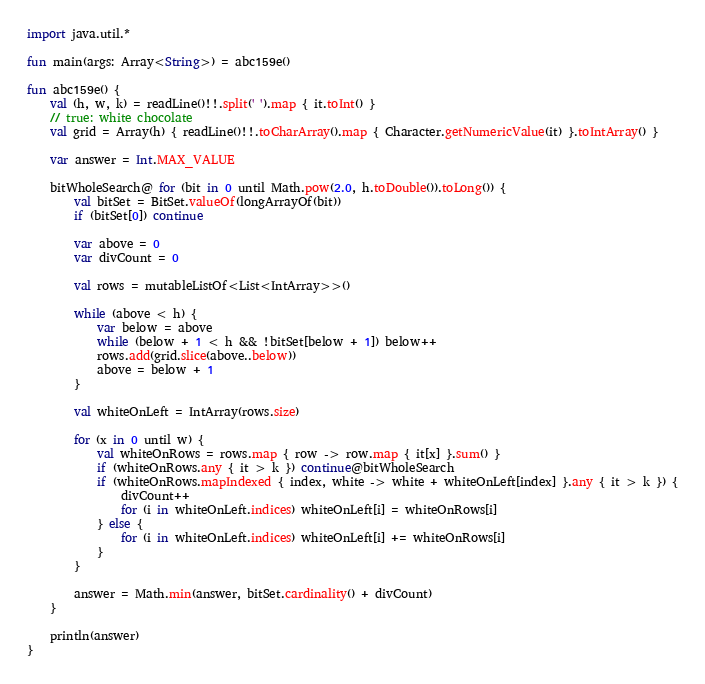Convert code to text. <code><loc_0><loc_0><loc_500><loc_500><_Kotlin_>import java.util.*

fun main(args: Array<String>) = abc159e()

fun abc159e() {
    val (h, w, k) = readLine()!!.split(' ').map { it.toInt() }
    // true: white chocolate
    val grid = Array(h) { readLine()!!.toCharArray().map { Character.getNumericValue(it) }.toIntArray() }

    var answer = Int.MAX_VALUE

    bitWholeSearch@ for (bit in 0 until Math.pow(2.0, h.toDouble()).toLong()) {
        val bitSet = BitSet.valueOf(longArrayOf(bit))
        if (bitSet[0]) continue

        var above = 0
        var divCount = 0

        val rows = mutableListOf<List<IntArray>>()

        while (above < h) {
            var below = above
            while (below + 1 < h && !bitSet[below + 1]) below++
            rows.add(grid.slice(above..below))
            above = below + 1
        }

        val whiteOnLeft = IntArray(rows.size)

        for (x in 0 until w) {
            val whiteOnRows = rows.map { row -> row.map { it[x] }.sum() }
            if (whiteOnRows.any { it > k }) continue@bitWholeSearch
            if (whiteOnRows.mapIndexed { index, white -> white + whiteOnLeft[index] }.any { it > k }) {
                divCount++
                for (i in whiteOnLeft.indices) whiteOnLeft[i] = whiteOnRows[i]
            } else {
                for (i in whiteOnLeft.indices) whiteOnLeft[i] += whiteOnRows[i]
            }
        }

        answer = Math.min(answer, bitSet.cardinality() + divCount)
    }

    println(answer)
}
</code> 